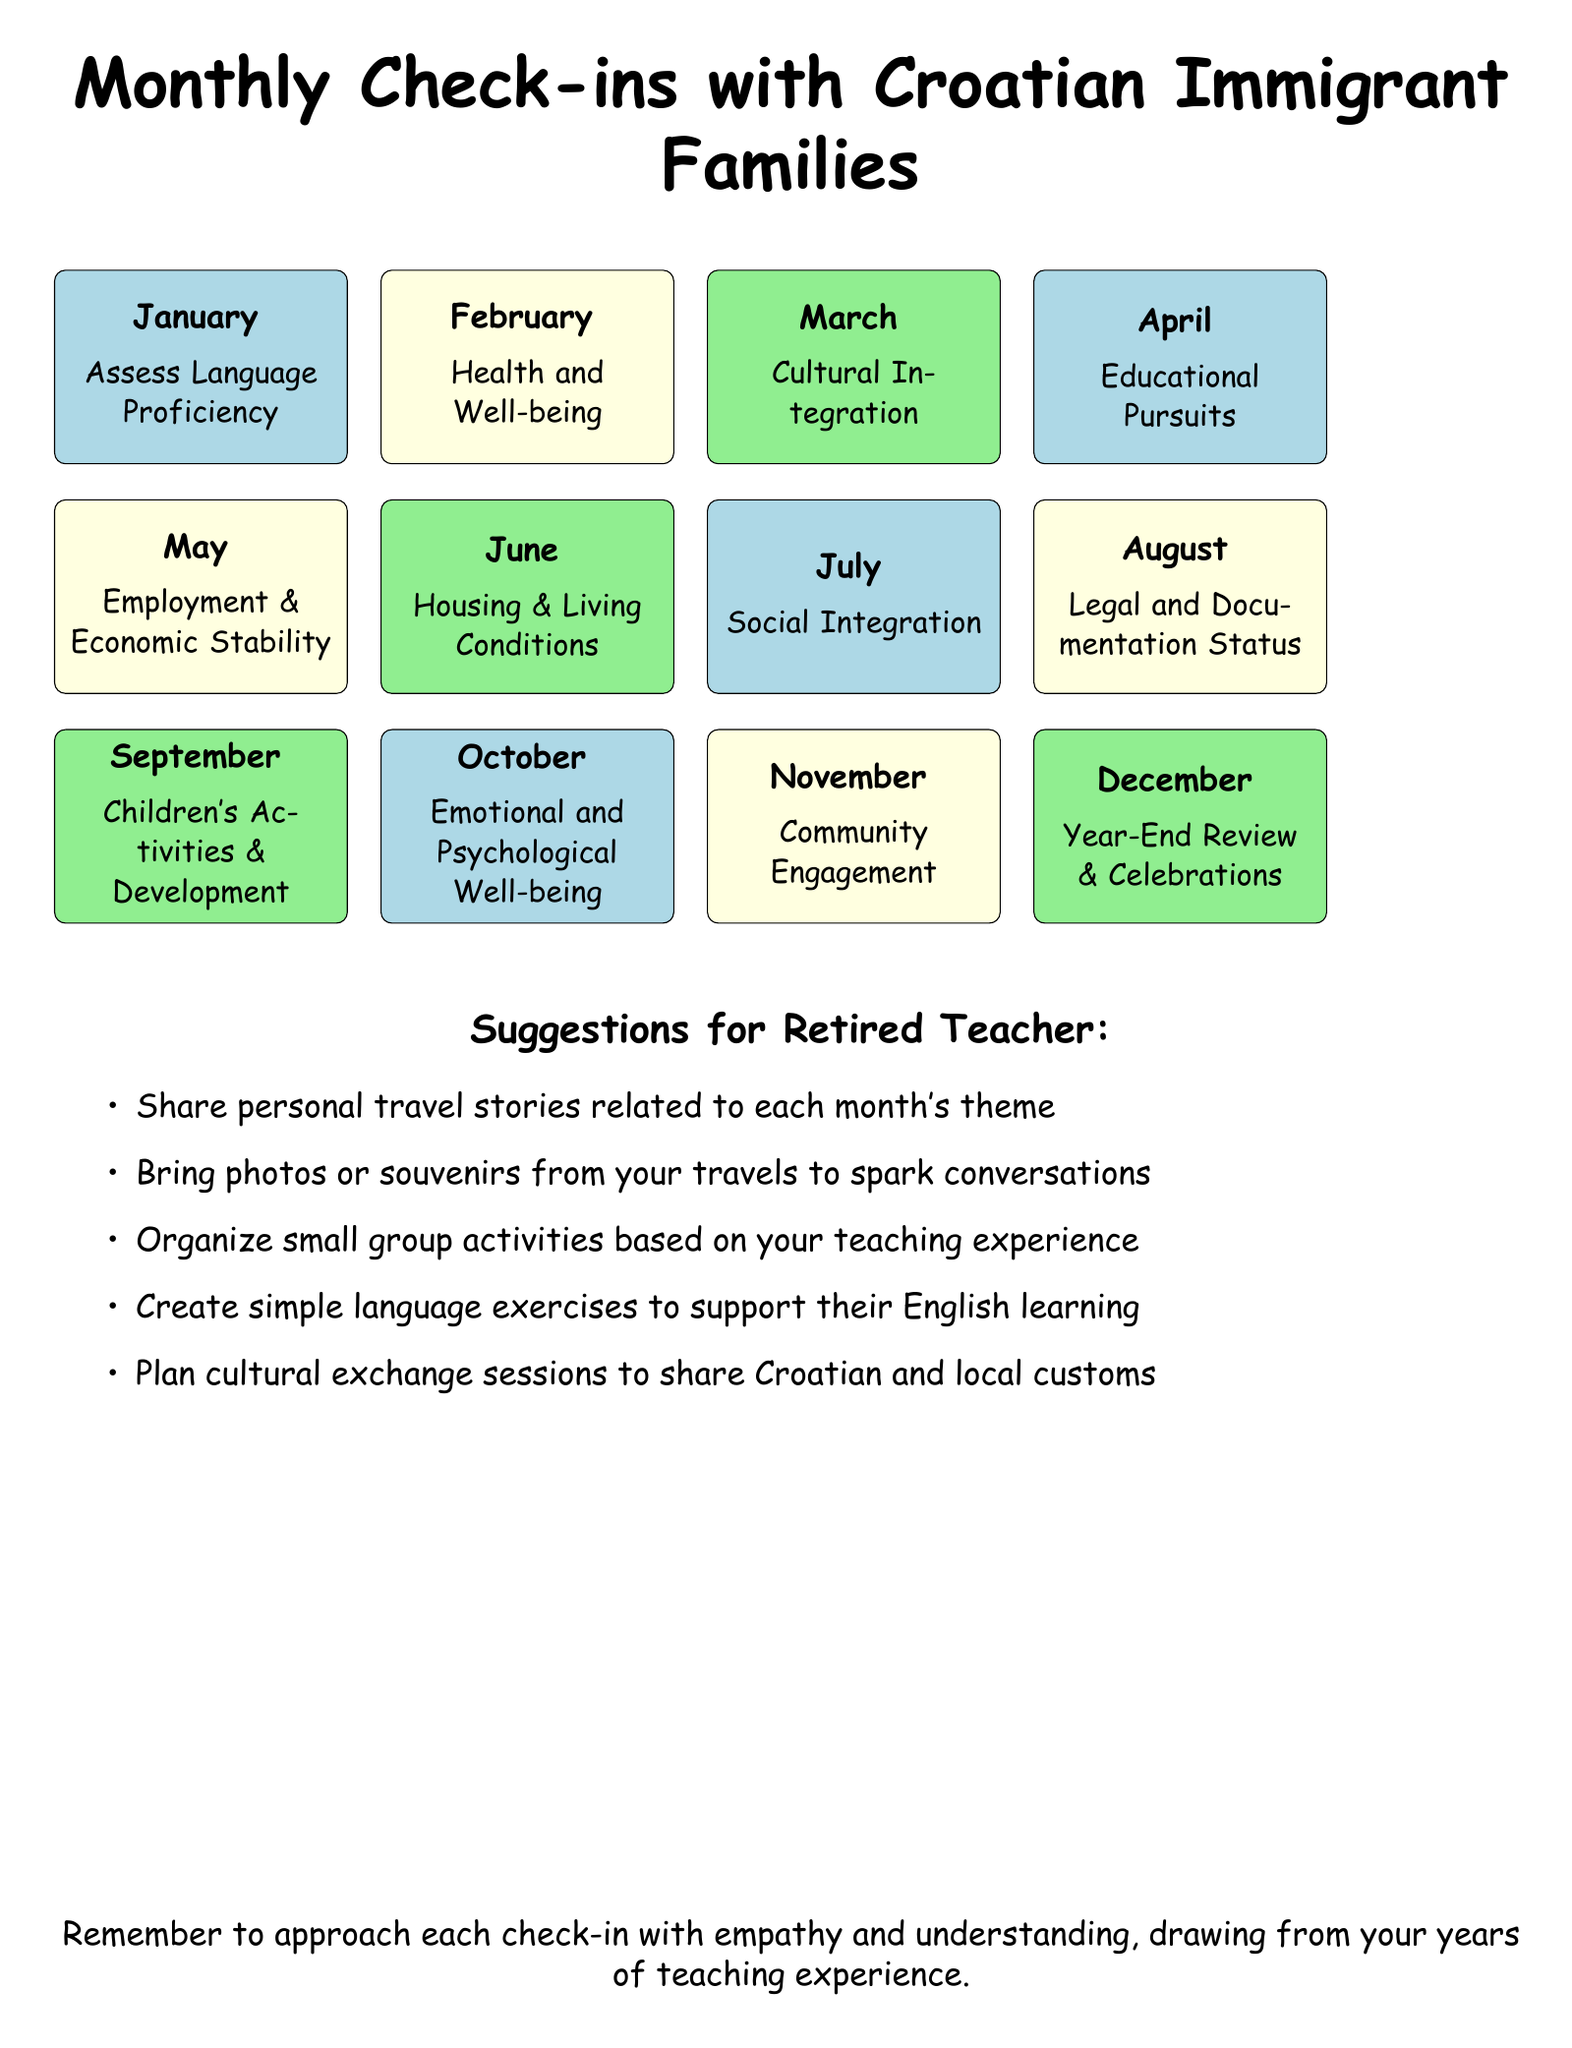What is the theme for January? The theme for January is the first month listed in the calendar, which is focused on assessing language skills.
Answer: Assess Language Proficiency Which month focuses on health and well-being? The month that focuses on health and well-being is specifically listed as February in the calendar.
Answer: February How many themes are listed for the year? The total number of themes is counted from the monthly check-ins provided in the document.
Answer: Twelve What is the theme for October? The theme for October is clearly stated as the focus for that month in the calendar.
Answer: Emotional and Psychological Well-being Which theme is scheduled for June? June is dedicated to assessing the living conditions of the families, as noted in the calendar.
Answer: Housing & Living Conditions What is one suggestion for the retired teacher? A specific suggestion for the retired teacher is detailed as part of the recommendations in the document.
Answer: Share personal travel stories related to each month's theme What is the purpose of the year-end review in December? The December review is meant for reflection and celebration based on the progress made throughout the year.
Answer: Year-End Review & Celebrations Which two months focus on lightblue themes? The months that center around lightblue themes can be found by analyzing the color coding of the document.
Answer: January and July What is the significance of community engagement in November? November's focus on community engagement is part of the ongoing support for integrating immigrant families into the local community.
Answer: Community Engagement 